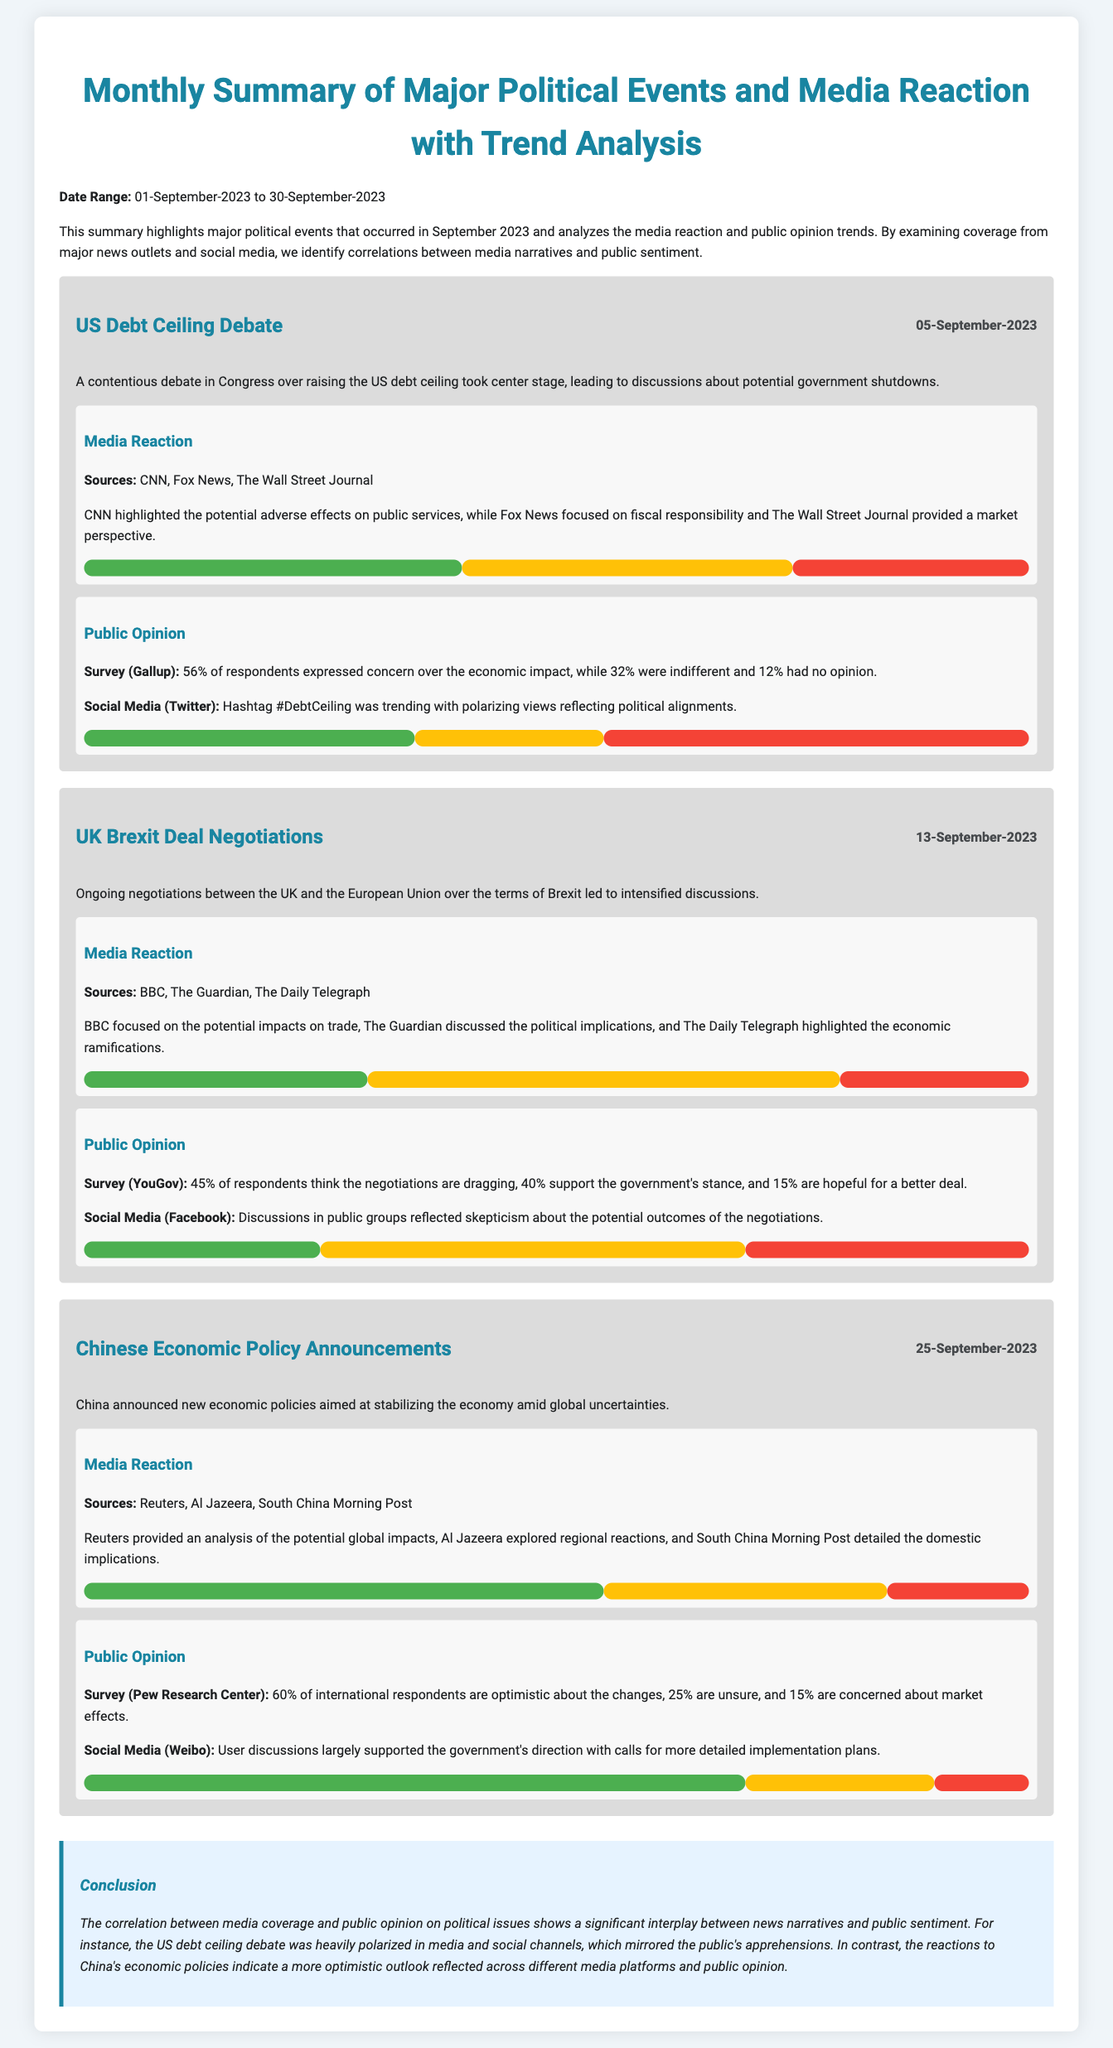What was the date of the US debt ceiling debate? The date of the US debt ceiling debate is explicitly stated in the document, which is 05-September-2023.
Answer: 05-September-2023 Which news outlet emphasized trade impacts during the UK Brexit deal negotiations? The document specifies that the BBC focused on the potential impacts on trade during the UK Brexit deal negotiations.
Answer: BBC What percentage of respondents in the Pew Research Center survey expressed optimism about China's economic changes? The document reports that 60% of international respondents in the Pew Research Center survey are optimistic about the changes.
Answer: 60% What was the general sentiment of media coverage regarding China's economic policy announcements? The document indicates that media coverage reflected a positive sentiment with 55% being positive, 30% neutral, and 15% negative.
Answer: Positive How did public opinion on the US debt ceiling issue trend according to social media? Social media discussions reflected polarizing views related to political alignments during the US debt ceiling debate.
Answer: Polarizing What was the conclusion regarding the relationship between media coverage and public opinion? The conclusion summarizes the correlation between media narratives and public sentiment, illustrating significant interplay in the findings.
Answer: Significant interplay What date range does the summary cover? The date range is provided in the document, covering 01-September-2023 to 30-September-2023.
Answer: 01-September-2023 to 30-September-2023 Which political event had the highest positive sentiment in media coverage according to the analysis? The analysis shows that the Chinese economic policy announcements had the highest positive sentiment in media coverage at 55%.
Answer: Chinese economic policy announcements 